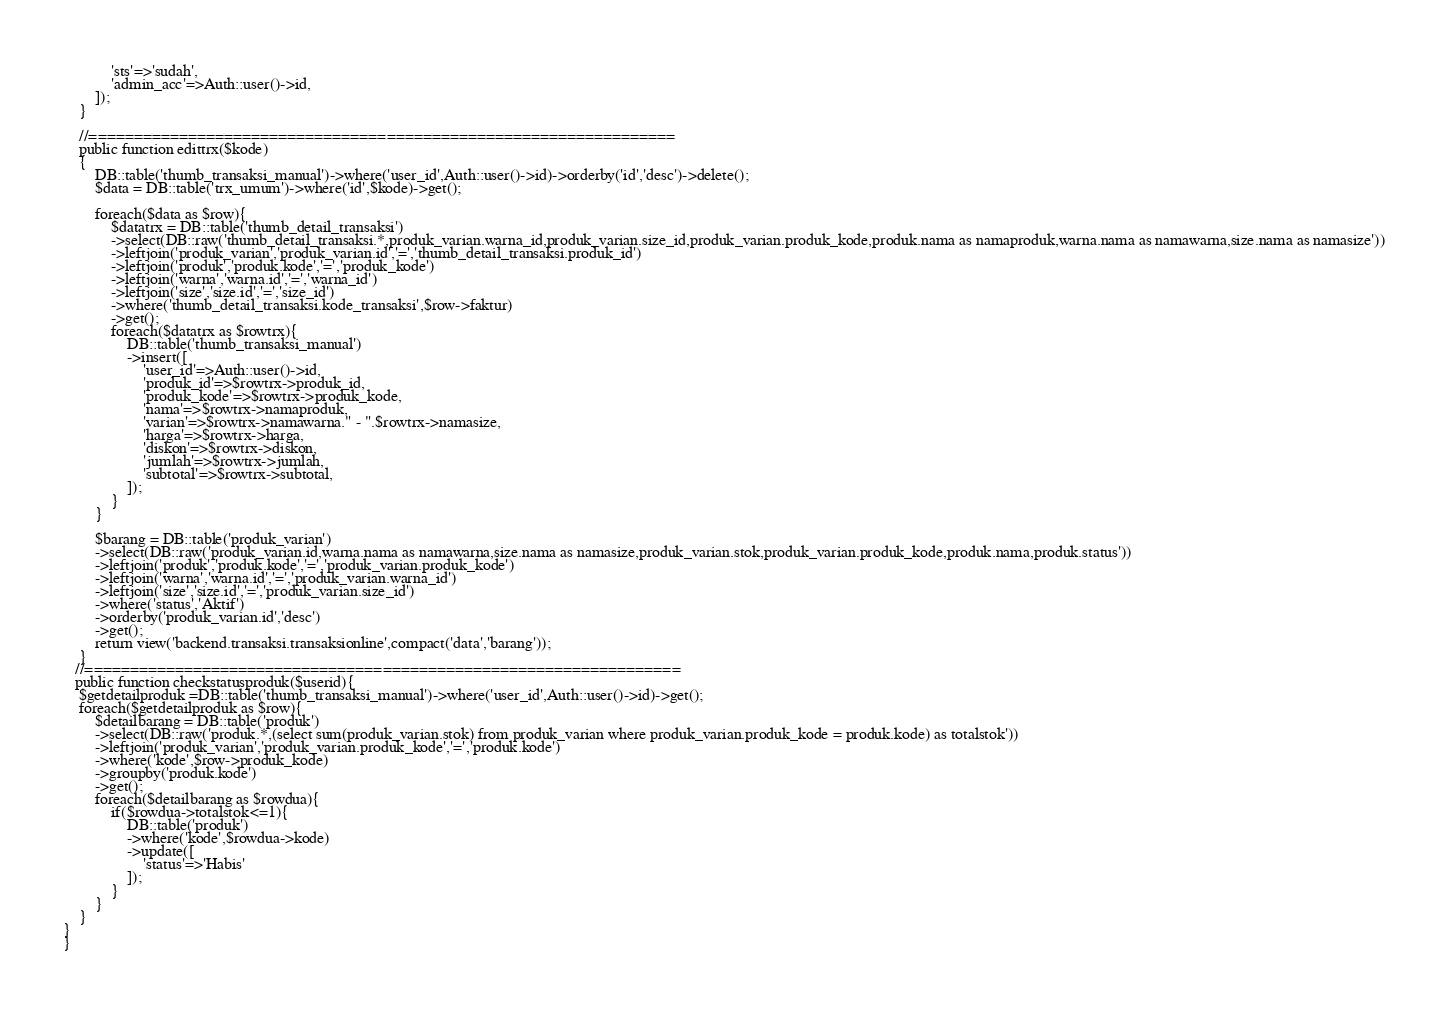Convert code to text. <code><loc_0><loc_0><loc_500><loc_500><_PHP_>            'sts'=>'sudah',
            'admin_acc'=>Auth::user()->id,
        ]);
    }

    //=================================================================
    public function edittrx($kode)
    {
        DB::table('thumb_transaksi_manual')->where('user_id',Auth::user()->id)->orderby('id','desc')->delete();
        $data = DB::table('trx_umum')->where('id',$kode)->get();

        foreach($data as $row){
            $datatrx = DB::table('thumb_detail_transaksi')
            ->select(DB::raw('thumb_detail_transaksi.*,produk_varian.warna_id,produk_varian.size_id,produk_varian.produk_kode,produk.nama as namaproduk,warna.nama as namawarna,size.nama as namasize'))
            ->leftjoin('produk_varian','produk_varian.id','=','thumb_detail_transaksi.produk_id')
            ->leftjoin('produk','produk.kode','=','produk_kode')
            ->leftjoin('warna','warna.id','=','warna_id')
            ->leftjoin('size','size.id','=','size_id')
            ->where('thumb_detail_transaksi.kode_transaksi',$row->faktur)
            ->get();
            foreach($datatrx as $rowtrx){
                DB::table('thumb_transaksi_manual')
                ->insert([
                    'user_id'=>Auth::user()->id,
                    'produk_id'=>$rowtrx->produk_id,
                    'produk_kode'=>$rowtrx->produk_kode,
                    'nama'=>$rowtrx->namaproduk,
                    'varian'=>$rowtrx->namawarna." - ".$rowtrx->namasize,
                    'harga'=>$rowtrx->harga,
                    'diskon'=>$rowtrx->diskon,
                    'jumlah'=>$rowtrx->jumlah,
                    'subtotal'=>$rowtrx->subtotal,
                ]);
            }
        }

        $barang = DB::table('produk_varian')
        ->select(DB::raw('produk_varian.id,warna.nama as namawarna,size.nama as namasize,produk_varian.stok,produk_varian.produk_kode,produk.nama,produk.status'))
        ->leftjoin('produk','produk.kode','=','produk_varian.produk_kode')
        ->leftjoin('warna','warna.id','=','produk_varian.warna_id')
        ->leftjoin('size','size.id','=','produk_varian.size_id')
        ->where('status','Aktif')
        ->orderby('produk_varian.id','desc')
        ->get();
        return view('backend.transaksi.transaksionline',compact('data','barang'));
    }
   //==================================================================
   public function checkstatusproduk($userid){
    $getdetailproduk =DB::table('thumb_transaksi_manual')->where('user_id',Auth::user()->id)->get();
    foreach($getdetailproduk as $row){
        $detailbarang = DB::table('produk')
        ->select(DB::raw('produk.*,(select sum(produk_varian.stok) from produk_varian where produk_varian.produk_kode = produk.kode) as totalstok'))
        ->leftjoin('produk_varian','produk_varian.produk_kode','=','produk.kode')
        ->where('kode',$row->produk_kode)
        ->groupby('produk.kode')
        ->get();
        foreach($detailbarang as $rowdua){
            if($rowdua->totalstok<=1){
                DB::table('produk')
                ->where('kode',$rowdua->kode)
                ->update([
                    'status'=>'Habis'
                ]);
            }
        }
    }
}
}</code> 